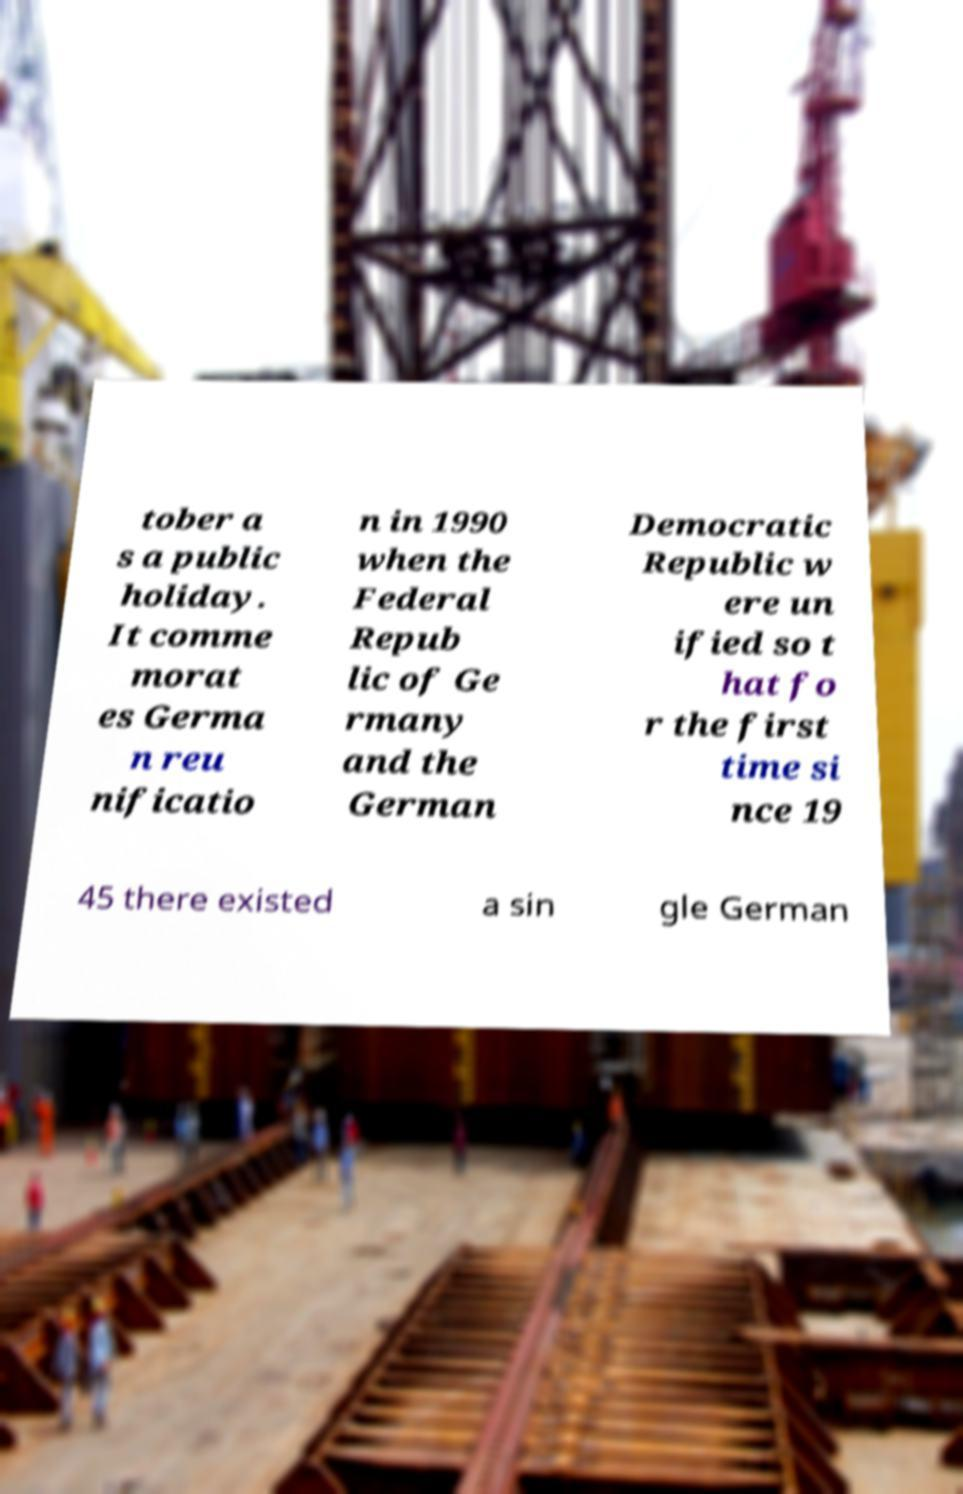Could you extract and type out the text from this image? tober a s a public holiday. It comme morat es Germa n reu nificatio n in 1990 when the Federal Repub lic of Ge rmany and the German Democratic Republic w ere un ified so t hat fo r the first time si nce 19 45 there existed a sin gle German 